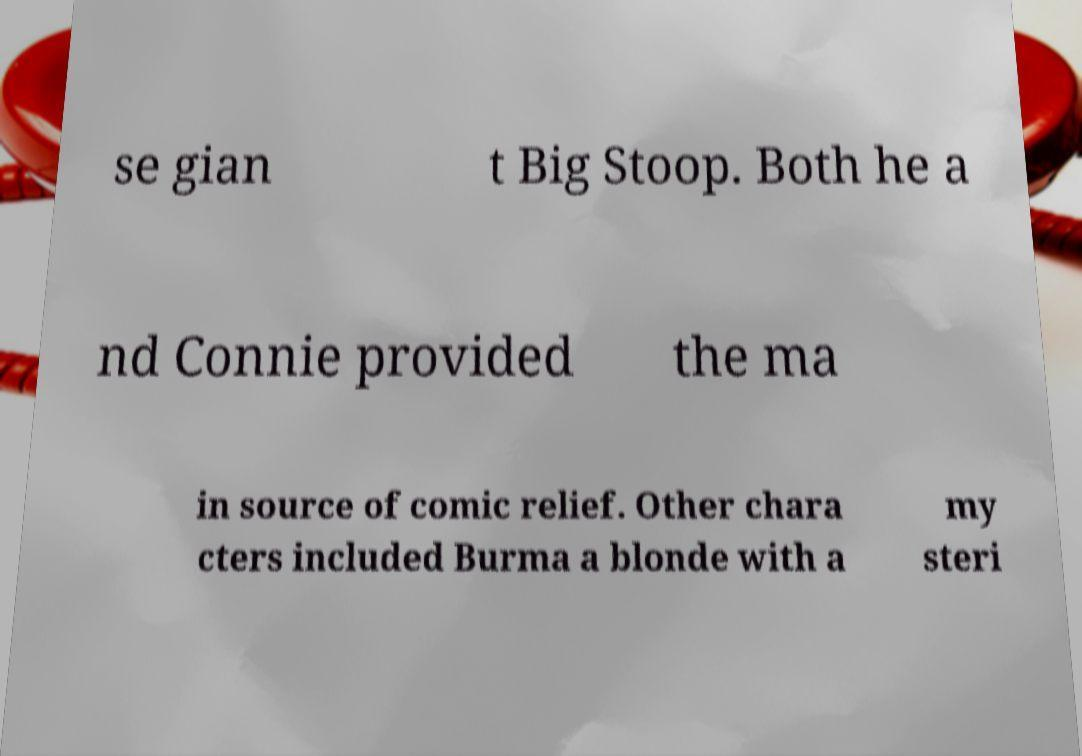Please identify and transcribe the text found in this image. se gian t Big Stoop. Both he a nd Connie provided the ma in source of comic relief. Other chara cters included Burma a blonde with a my steri 